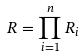Convert formula to latex. <formula><loc_0><loc_0><loc_500><loc_500>R = \prod _ { i = 1 } ^ { n } R _ { i }</formula> 